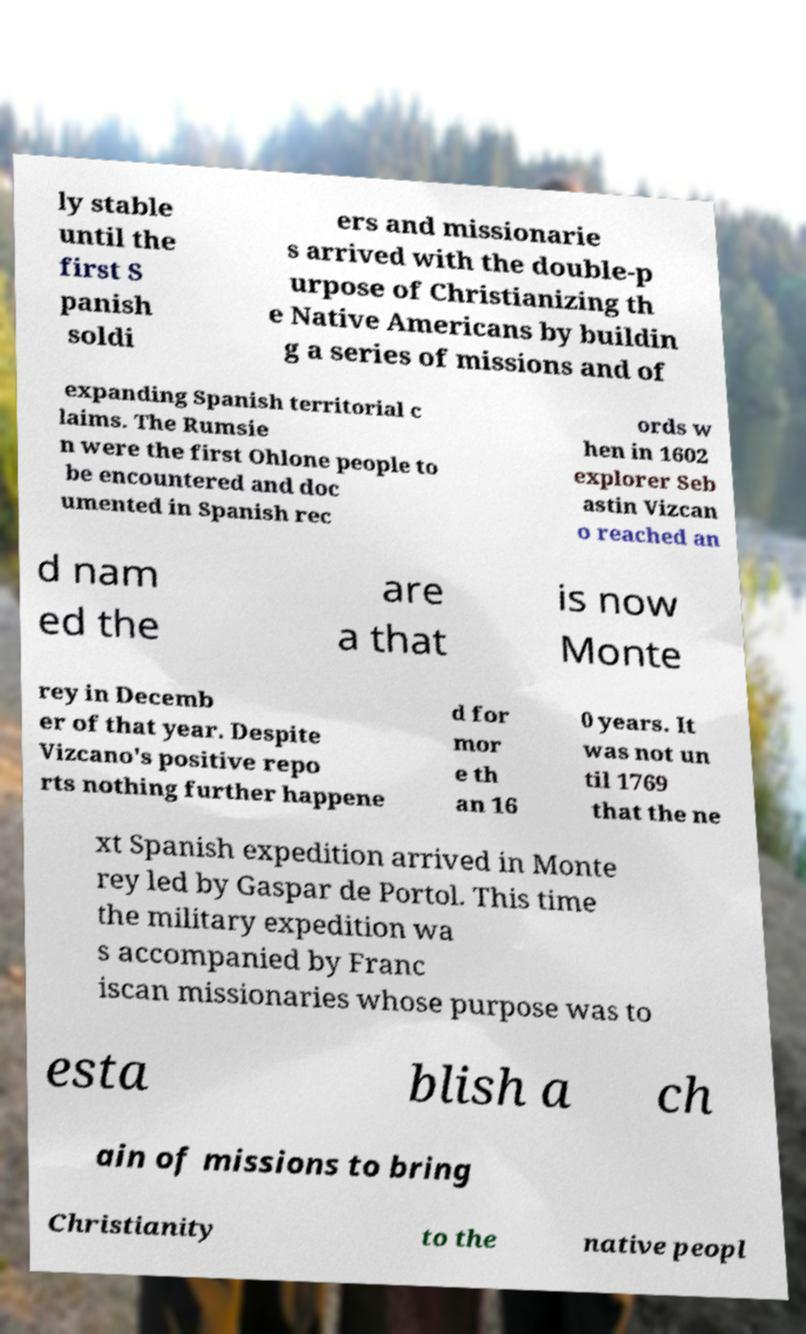There's text embedded in this image that I need extracted. Can you transcribe it verbatim? ly stable until the first S panish soldi ers and missionarie s arrived with the double-p urpose of Christianizing th e Native Americans by buildin g a series of missions and of expanding Spanish territorial c laims. The Rumsie n were the first Ohlone people to be encountered and doc umented in Spanish rec ords w hen in 1602 explorer Seb astin Vizcan o reached an d nam ed the are a that is now Monte rey in Decemb er of that year. Despite Vizcano's positive repo rts nothing further happene d for mor e th an 16 0 years. It was not un til 1769 that the ne xt Spanish expedition arrived in Monte rey led by Gaspar de Portol. This time the military expedition wa s accompanied by Franc iscan missionaries whose purpose was to esta blish a ch ain of missions to bring Christianity to the native peopl 